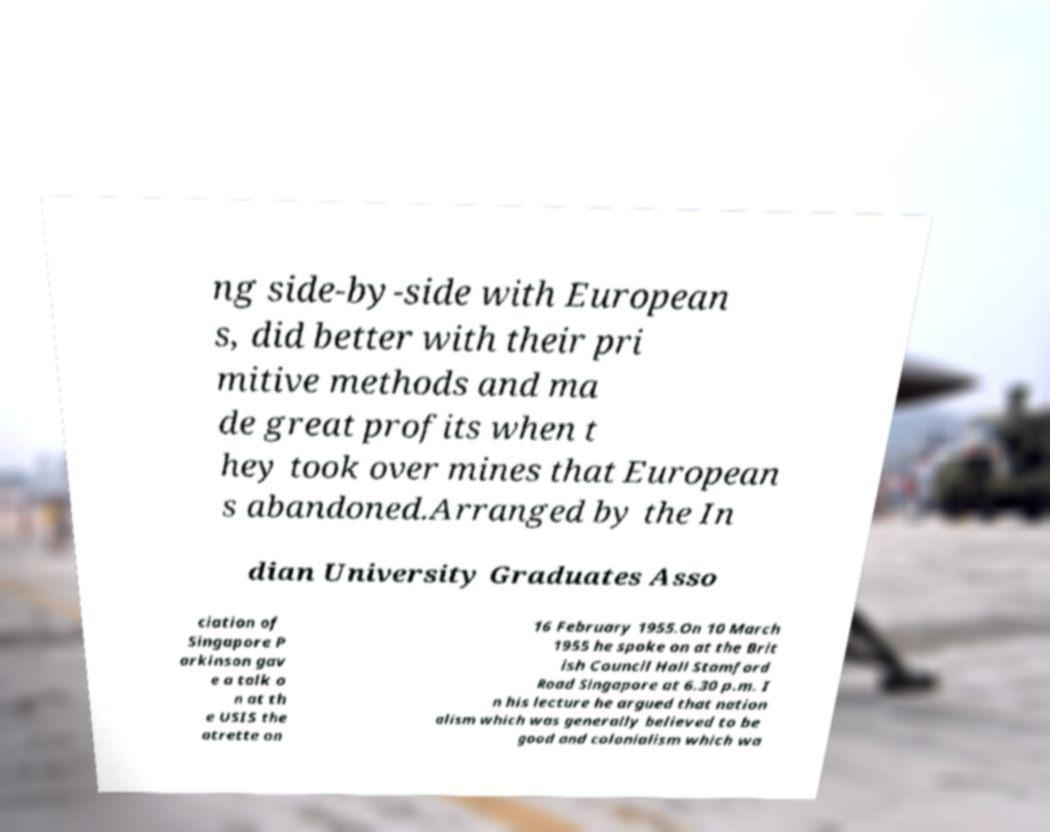Can you accurately transcribe the text from the provided image for me? ng side-by-side with European s, did better with their pri mitive methods and ma de great profits when t hey took over mines that European s abandoned.Arranged by the In dian University Graduates Asso ciation of Singapore P arkinson gav e a talk o n at th e USIS the atrette on 16 February 1955.On 10 March 1955 he spoke on at the Brit ish Council Hall Stamford Road Singapore at 6.30 p.m. I n his lecture he argued that nation alism which was generally believed to be good and colonialism which wa 